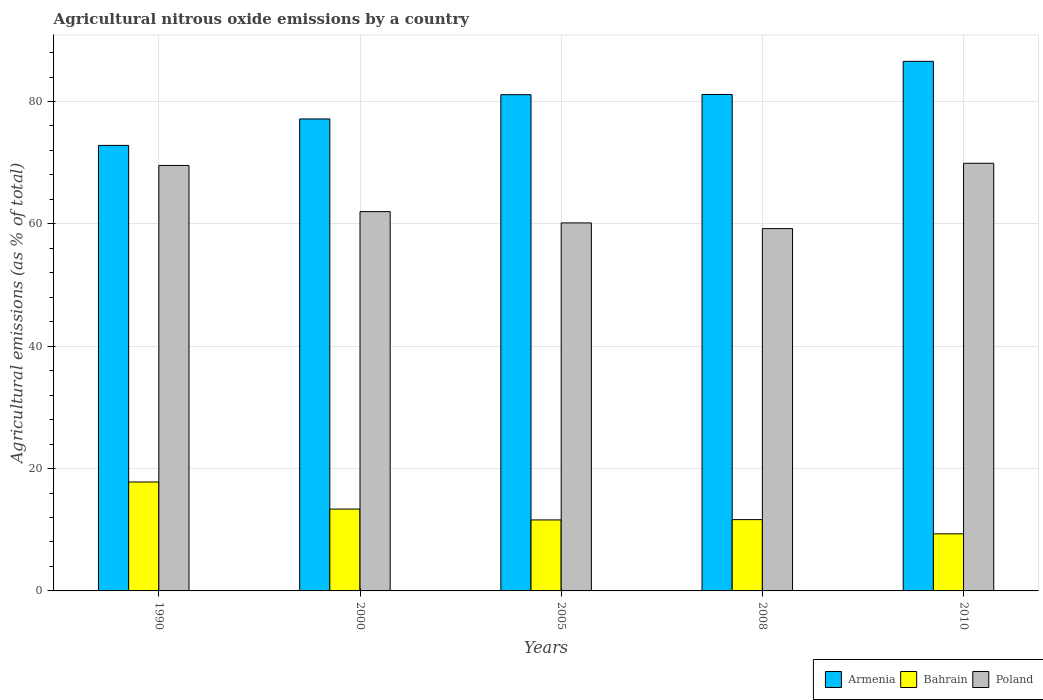How many different coloured bars are there?
Your response must be concise. 3. How many groups of bars are there?
Provide a short and direct response. 5. Are the number of bars on each tick of the X-axis equal?
Your answer should be compact. Yes. How many bars are there on the 2nd tick from the left?
Your response must be concise. 3. In how many cases, is the number of bars for a given year not equal to the number of legend labels?
Your answer should be compact. 0. What is the amount of agricultural nitrous oxide emitted in Bahrain in 2010?
Provide a short and direct response. 9.33. Across all years, what is the maximum amount of agricultural nitrous oxide emitted in Armenia?
Give a very brief answer. 86.56. Across all years, what is the minimum amount of agricultural nitrous oxide emitted in Poland?
Keep it short and to the point. 59.22. What is the total amount of agricultural nitrous oxide emitted in Poland in the graph?
Keep it short and to the point. 320.82. What is the difference between the amount of agricultural nitrous oxide emitted in Poland in 2000 and that in 2005?
Ensure brevity in your answer.  1.85. What is the difference between the amount of agricultural nitrous oxide emitted in Bahrain in 2008 and the amount of agricultural nitrous oxide emitted in Armenia in 2005?
Offer a terse response. -69.46. What is the average amount of agricultural nitrous oxide emitted in Armenia per year?
Give a very brief answer. 79.76. In the year 2010, what is the difference between the amount of agricultural nitrous oxide emitted in Bahrain and amount of agricultural nitrous oxide emitted in Armenia?
Offer a terse response. -77.23. What is the ratio of the amount of agricultural nitrous oxide emitted in Armenia in 1990 to that in 2008?
Give a very brief answer. 0.9. Is the amount of agricultural nitrous oxide emitted in Poland in 2005 less than that in 2008?
Your answer should be compact. No. What is the difference between the highest and the second highest amount of agricultural nitrous oxide emitted in Armenia?
Provide a succinct answer. 5.41. What is the difference between the highest and the lowest amount of agricultural nitrous oxide emitted in Poland?
Your response must be concise. 10.68. In how many years, is the amount of agricultural nitrous oxide emitted in Poland greater than the average amount of agricultural nitrous oxide emitted in Poland taken over all years?
Your answer should be very brief. 2. Is the sum of the amount of agricultural nitrous oxide emitted in Armenia in 2005 and 2008 greater than the maximum amount of agricultural nitrous oxide emitted in Poland across all years?
Provide a short and direct response. Yes. What does the 3rd bar from the right in 2000 represents?
Your answer should be very brief. Armenia. How many bars are there?
Make the answer very short. 15. Are all the bars in the graph horizontal?
Offer a terse response. No. Does the graph contain any zero values?
Give a very brief answer. No. Where does the legend appear in the graph?
Provide a succinct answer. Bottom right. How many legend labels are there?
Provide a succinct answer. 3. How are the legend labels stacked?
Your answer should be very brief. Horizontal. What is the title of the graph?
Provide a succinct answer. Agricultural nitrous oxide emissions by a country. Does "Cyprus" appear as one of the legend labels in the graph?
Provide a succinct answer. No. What is the label or title of the X-axis?
Your response must be concise. Years. What is the label or title of the Y-axis?
Provide a succinct answer. Agricultural emissions (as % of total). What is the Agricultural emissions (as % of total) in Armenia in 1990?
Provide a short and direct response. 72.82. What is the Agricultural emissions (as % of total) in Bahrain in 1990?
Provide a succinct answer. 17.81. What is the Agricultural emissions (as % of total) of Poland in 1990?
Ensure brevity in your answer.  69.54. What is the Agricultural emissions (as % of total) in Armenia in 2000?
Make the answer very short. 77.14. What is the Agricultural emissions (as % of total) in Bahrain in 2000?
Ensure brevity in your answer.  13.38. What is the Agricultural emissions (as % of total) of Poland in 2000?
Offer a very short reply. 62. What is the Agricultural emissions (as % of total) of Armenia in 2005?
Offer a terse response. 81.11. What is the Agricultural emissions (as % of total) in Bahrain in 2005?
Offer a terse response. 11.6. What is the Agricultural emissions (as % of total) of Poland in 2005?
Give a very brief answer. 60.15. What is the Agricultural emissions (as % of total) of Armenia in 2008?
Ensure brevity in your answer.  81.15. What is the Agricultural emissions (as % of total) in Bahrain in 2008?
Keep it short and to the point. 11.65. What is the Agricultural emissions (as % of total) in Poland in 2008?
Offer a terse response. 59.22. What is the Agricultural emissions (as % of total) of Armenia in 2010?
Give a very brief answer. 86.56. What is the Agricultural emissions (as % of total) in Bahrain in 2010?
Offer a terse response. 9.33. What is the Agricultural emissions (as % of total) in Poland in 2010?
Provide a short and direct response. 69.9. Across all years, what is the maximum Agricultural emissions (as % of total) of Armenia?
Make the answer very short. 86.56. Across all years, what is the maximum Agricultural emissions (as % of total) of Bahrain?
Your response must be concise. 17.81. Across all years, what is the maximum Agricultural emissions (as % of total) in Poland?
Your response must be concise. 69.9. Across all years, what is the minimum Agricultural emissions (as % of total) in Armenia?
Provide a short and direct response. 72.82. Across all years, what is the minimum Agricultural emissions (as % of total) in Bahrain?
Offer a terse response. 9.33. Across all years, what is the minimum Agricultural emissions (as % of total) in Poland?
Provide a short and direct response. 59.22. What is the total Agricultural emissions (as % of total) in Armenia in the graph?
Offer a very short reply. 398.78. What is the total Agricultural emissions (as % of total) in Bahrain in the graph?
Your answer should be compact. 63.77. What is the total Agricultural emissions (as % of total) in Poland in the graph?
Keep it short and to the point. 320.82. What is the difference between the Agricultural emissions (as % of total) in Armenia in 1990 and that in 2000?
Your answer should be compact. -4.32. What is the difference between the Agricultural emissions (as % of total) in Bahrain in 1990 and that in 2000?
Offer a very short reply. 4.43. What is the difference between the Agricultural emissions (as % of total) of Poland in 1990 and that in 2000?
Your answer should be compact. 7.54. What is the difference between the Agricultural emissions (as % of total) of Armenia in 1990 and that in 2005?
Provide a short and direct response. -8.29. What is the difference between the Agricultural emissions (as % of total) of Bahrain in 1990 and that in 2005?
Your answer should be very brief. 6.2. What is the difference between the Agricultural emissions (as % of total) of Poland in 1990 and that in 2005?
Your answer should be very brief. 9.39. What is the difference between the Agricultural emissions (as % of total) of Armenia in 1990 and that in 2008?
Your answer should be compact. -8.33. What is the difference between the Agricultural emissions (as % of total) in Bahrain in 1990 and that in 2008?
Give a very brief answer. 6.15. What is the difference between the Agricultural emissions (as % of total) of Poland in 1990 and that in 2008?
Offer a terse response. 10.32. What is the difference between the Agricultural emissions (as % of total) in Armenia in 1990 and that in 2010?
Your response must be concise. -13.74. What is the difference between the Agricultural emissions (as % of total) in Bahrain in 1990 and that in 2010?
Offer a terse response. 8.47. What is the difference between the Agricultural emissions (as % of total) of Poland in 1990 and that in 2010?
Provide a succinct answer. -0.36. What is the difference between the Agricultural emissions (as % of total) in Armenia in 2000 and that in 2005?
Ensure brevity in your answer.  -3.97. What is the difference between the Agricultural emissions (as % of total) in Bahrain in 2000 and that in 2005?
Provide a short and direct response. 1.78. What is the difference between the Agricultural emissions (as % of total) in Poland in 2000 and that in 2005?
Keep it short and to the point. 1.85. What is the difference between the Agricultural emissions (as % of total) of Armenia in 2000 and that in 2008?
Offer a very short reply. -4. What is the difference between the Agricultural emissions (as % of total) in Bahrain in 2000 and that in 2008?
Your response must be concise. 1.72. What is the difference between the Agricultural emissions (as % of total) of Poland in 2000 and that in 2008?
Make the answer very short. 2.78. What is the difference between the Agricultural emissions (as % of total) in Armenia in 2000 and that in 2010?
Your answer should be very brief. -9.42. What is the difference between the Agricultural emissions (as % of total) of Bahrain in 2000 and that in 2010?
Offer a very short reply. 4.05. What is the difference between the Agricultural emissions (as % of total) of Poland in 2000 and that in 2010?
Your answer should be very brief. -7.9. What is the difference between the Agricultural emissions (as % of total) in Armenia in 2005 and that in 2008?
Keep it short and to the point. -0.03. What is the difference between the Agricultural emissions (as % of total) of Bahrain in 2005 and that in 2008?
Provide a succinct answer. -0.05. What is the difference between the Agricultural emissions (as % of total) of Poland in 2005 and that in 2008?
Keep it short and to the point. 0.93. What is the difference between the Agricultural emissions (as % of total) of Armenia in 2005 and that in 2010?
Make the answer very short. -5.45. What is the difference between the Agricultural emissions (as % of total) in Bahrain in 2005 and that in 2010?
Give a very brief answer. 2.27. What is the difference between the Agricultural emissions (as % of total) in Poland in 2005 and that in 2010?
Offer a terse response. -9.75. What is the difference between the Agricultural emissions (as % of total) in Armenia in 2008 and that in 2010?
Provide a short and direct response. -5.41. What is the difference between the Agricultural emissions (as % of total) of Bahrain in 2008 and that in 2010?
Ensure brevity in your answer.  2.32. What is the difference between the Agricultural emissions (as % of total) of Poland in 2008 and that in 2010?
Your answer should be very brief. -10.68. What is the difference between the Agricultural emissions (as % of total) of Armenia in 1990 and the Agricultural emissions (as % of total) of Bahrain in 2000?
Keep it short and to the point. 59.44. What is the difference between the Agricultural emissions (as % of total) in Armenia in 1990 and the Agricultural emissions (as % of total) in Poland in 2000?
Keep it short and to the point. 10.82. What is the difference between the Agricultural emissions (as % of total) in Bahrain in 1990 and the Agricultural emissions (as % of total) in Poland in 2000?
Offer a very short reply. -44.19. What is the difference between the Agricultural emissions (as % of total) of Armenia in 1990 and the Agricultural emissions (as % of total) of Bahrain in 2005?
Make the answer very short. 61.22. What is the difference between the Agricultural emissions (as % of total) of Armenia in 1990 and the Agricultural emissions (as % of total) of Poland in 2005?
Your answer should be very brief. 12.67. What is the difference between the Agricultural emissions (as % of total) of Bahrain in 1990 and the Agricultural emissions (as % of total) of Poland in 2005?
Your answer should be compact. -42.35. What is the difference between the Agricultural emissions (as % of total) in Armenia in 1990 and the Agricultural emissions (as % of total) in Bahrain in 2008?
Your response must be concise. 61.17. What is the difference between the Agricultural emissions (as % of total) in Armenia in 1990 and the Agricultural emissions (as % of total) in Poland in 2008?
Provide a short and direct response. 13.6. What is the difference between the Agricultural emissions (as % of total) in Bahrain in 1990 and the Agricultural emissions (as % of total) in Poland in 2008?
Keep it short and to the point. -41.41. What is the difference between the Agricultural emissions (as % of total) of Armenia in 1990 and the Agricultural emissions (as % of total) of Bahrain in 2010?
Ensure brevity in your answer.  63.49. What is the difference between the Agricultural emissions (as % of total) of Armenia in 1990 and the Agricultural emissions (as % of total) of Poland in 2010?
Your response must be concise. 2.92. What is the difference between the Agricultural emissions (as % of total) in Bahrain in 1990 and the Agricultural emissions (as % of total) in Poland in 2010?
Give a very brief answer. -52.09. What is the difference between the Agricultural emissions (as % of total) in Armenia in 2000 and the Agricultural emissions (as % of total) in Bahrain in 2005?
Ensure brevity in your answer.  65.54. What is the difference between the Agricultural emissions (as % of total) in Armenia in 2000 and the Agricultural emissions (as % of total) in Poland in 2005?
Give a very brief answer. 16.99. What is the difference between the Agricultural emissions (as % of total) in Bahrain in 2000 and the Agricultural emissions (as % of total) in Poland in 2005?
Offer a terse response. -46.77. What is the difference between the Agricultural emissions (as % of total) of Armenia in 2000 and the Agricultural emissions (as % of total) of Bahrain in 2008?
Your answer should be compact. 65.49. What is the difference between the Agricultural emissions (as % of total) of Armenia in 2000 and the Agricultural emissions (as % of total) of Poland in 2008?
Offer a terse response. 17.92. What is the difference between the Agricultural emissions (as % of total) of Bahrain in 2000 and the Agricultural emissions (as % of total) of Poland in 2008?
Your answer should be compact. -45.84. What is the difference between the Agricultural emissions (as % of total) in Armenia in 2000 and the Agricultural emissions (as % of total) in Bahrain in 2010?
Provide a short and direct response. 67.81. What is the difference between the Agricultural emissions (as % of total) of Armenia in 2000 and the Agricultural emissions (as % of total) of Poland in 2010?
Provide a short and direct response. 7.24. What is the difference between the Agricultural emissions (as % of total) in Bahrain in 2000 and the Agricultural emissions (as % of total) in Poland in 2010?
Offer a very short reply. -56.52. What is the difference between the Agricultural emissions (as % of total) in Armenia in 2005 and the Agricultural emissions (as % of total) in Bahrain in 2008?
Provide a short and direct response. 69.46. What is the difference between the Agricultural emissions (as % of total) of Armenia in 2005 and the Agricultural emissions (as % of total) of Poland in 2008?
Your answer should be compact. 21.89. What is the difference between the Agricultural emissions (as % of total) of Bahrain in 2005 and the Agricultural emissions (as % of total) of Poland in 2008?
Your response must be concise. -47.62. What is the difference between the Agricultural emissions (as % of total) of Armenia in 2005 and the Agricultural emissions (as % of total) of Bahrain in 2010?
Your answer should be very brief. 71.78. What is the difference between the Agricultural emissions (as % of total) of Armenia in 2005 and the Agricultural emissions (as % of total) of Poland in 2010?
Make the answer very short. 11.21. What is the difference between the Agricultural emissions (as % of total) of Bahrain in 2005 and the Agricultural emissions (as % of total) of Poland in 2010?
Provide a short and direct response. -58.3. What is the difference between the Agricultural emissions (as % of total) in Armenia in 2008 and the Agricultural emissions (as % of total) in Bahrain in 2010?
Give a very brief answer. 71.81. What is the difference between the Agricultural emissions (as % of total) in Armenia in 2008 and the Agricultural emissions (as % of total) in Poland in 2010?
Offer a very short reply. 11.25. What is the difference between the Agricultural emissions (as % of total) in Bahrain in 2008 and the Agricultural emissions (as % of total) in Poland in 2010?
Ensure brevity in your answer.  -58.25. What is the average Agricultural emissions (as % of total) of Armenia per year?
Provide a short and direct response. 79.76. What is the average Agricultural emissions (as % of total) in Bahrain per year?
Offer a very short reply. 12.75. What is the average Agricultural emissions (as % of total) of Poland per year?
Make the answer very short. 64.16. In the year 1990, what is the difference between the Agricultural emissions (as % of total) in Armenia and Agricultural emissions (as % of total) in Bahrain?
Offer a terse response. 55.01. In the year 1990, what is the difference between the Agricultural emissions (as % of total) of Armenia and Agricultural emissions (as % of total) of Poland?
Offer a very short reply. 3.28. In the year 1990, what is the difference between the Agricultural emissions (as % of total) in Bahrain and Agricultural emissions (as % of total) in Poland?
Make the answer very short. -51.74. In the year 2000, what is the difference between the Agricultural emissions (as % of total) of Armenia and Agricultural emissions (as % of total) of Bahrain?
Provide a short and direct response. 63.77. In the year 2000, what is the difference between the Agricultural emissions (as % of total) in Armenia and Agricultural emissions (as % of total) in Poland?
Offer a very short reply. 15.14. In the year 2000, what is the difference between the Agricultural emissions (as % of total) in Bahrain and Agricultural emissions (as % of total) in Poland?
Give a very brief answer. -48.62. In the year 2005, what is the difference between the Agricultural emissions (as % of total) in Armenia and Agricultural emissions (as % of total) in Bahrain?
Make the answer very short. 69.51. In the year 2005, what is the difference between the Agricultural emissions (as % of total) of Armenia and Agricultural emissions (as % of total) of Poland?
Your answer should be compact. 20.96. In the year 2005, what is the difference between the Agricultural emissions (as % of total) in Bahrain and Agricultural emissions (as % of total) in Poland?
Give a very brief answer. -48.55. In the year 2008, what is the difference between the Agricultural emissions (as % of total) in Armenia and Agricultural emissions (as % of total) in Bahrain?
Keep it short and to the point. 69.49. In the year 2008, what is the difference between the Agricultural emissions (as % of total) of Armenia and Agricultural emissions (as % of total) of Poland?
Your response must be concise. 21.93. In the year 2008, what is the difference between the Agricultural emissions (as % of total) in Bahrain and Agricultural emissions (as % of total) in Poland?
Ensure brevity in your answer.  -47.57. In the year 2010, what is the difference between the Agricultural emissions (as % of total) of Armenia and Agricultural emissions (as % of total) of Bahrain?
Provide a succinct answer. 77.23. In the year 2010, what is the difference between the Agricultural emissions (as % of total) of Armenia and Agricultural emissions (as % of total) of Poland?
Your response must be concise. 16.66. In the year 2010, what is the difference between the Agricultural emissions (as % of total) in Bahrain and Agricultural emissions (as % of total) in Poland?
Offer a terse response. -60.57. What is the ratio of the Agricultural emissions (as % of total) of Armenia in 1990 to that in 2000?
Provide a short and direct response. 0.94. What is the ratio of the Agricultural emissions (as % of total) of Bahrain in 1990 to that in 2000?
Keep it short and to the point. 1.33. What is the ratio of the Agricultural emissions (as % of total) of Poland in 1990 to that in 2000?
Offer a terse response. 1.12. What is the ratio of the Agricultural emissions (as % of total) of Armenia in 1990 to that in 2005?
Offer a terse response. 0.9. What is the ratio of the Agricultural emissions (as % of total) of Bahrain in 1990 to that in 2005?
Keep it short and to the point. 1.53. What is the ratio of the Agricultural emissions (as % of total) in Poland in 1990 to that in 2005?
Give a very brief answer. 1.16. What is the ratio of the Agricultural emissions (as % of total) of Armenia in 1990 to that in 2008?
Keep it short and to the point. 0.9. What is the ratio of the Agricultural emissions (as % of total) in Bahrain in 1990 to that in 2008?
Your answer should be compact. 1.53. What is the ratio of the Agricultural emissions (as % of total) in Poland in 1990 to that in 2008?
Provide a succinct answer. 1.17. What is the ratio of the Agricultural emissions (as % of total) of Armenia in 1990 to that in 2010?
Give a very brief answer. 0.84. What is the ratio of the Agricultural emissions (as % of total) of Bahrain in 1990 to that in 2010?
Provide a short and direct response. 1.91. What is the ratio of the Agricultural emissions (as % of total) in Poland in 1990 to that in 2010?
Give a very brief answer. 0.99. What is the ratio of the Agricultural emissions (as % of total) in Armenia in 2000 to that in 2005?
Keep it short and to the point. 0.95. What is the ratio of the Agricultural emissions (as % of total) in Bahrain in 2000 to that in 2005?
Ensure brevity in your answer.  1.15. What is the ratio of the Agricultural emissions (as % of total) of Poland in 2000 to that in 2005?
Make the answer very short. 1.03. What is the ratio of the Agricultural emissions (as % of total) in Armenia in 2000 to that in 2008?
Ensure brevity in your answer.  0.95. What is the ratio of the Agricultural emissions (as % of total) of Bahrain in 2000 to that in 2008?
Ensure brevity in your answer.  1.15. What is the ratio of the Agricultural emissions (as % of total) of Poland in 2000 to that in 2008?
Provide a succinct answer. 1.05. What is the ratio of the Agricultural emissions (as % of total) of Armenia in 2000 to that in 2010?
Your response must be concise. 0.89. What is the ratio of the Agricultural emissions (as % of total) of Bahrain in 2000 to that in 2010?
Make the answer very short. 1.43. What is the ratio of the Agricultural emissions (as % of total) of Poland in 2000 to that in 2010?
Provide a succinct answer. 0.89. What is the ratio of the Agricultural emissions (as % of total) of Armenia in 2005 to that in 2008?
Provide a succinct answer. 1. What is the ratio of the Agricultural emissions (as % of total) in Bahrain in 2005 to that in 2008?
Keep it short and to the point. 1. What is the ratio of the Agricultural emissions (as % of total) in Poland in 2005 to that in 2008?
Provide a succinct answer. 1.02. What is the ratio of the Agricultural emissions (as % of total) of Armenia in 2005 to that in 2010?
Your answer should be very brief. 0.94. What is the ratio of the Agricultural emissions (as % of total) of Bahrain in 2005 to that in 2010?
Give a very brief answer. 1.24. What is the ratio of the Agricultural emissions (as % of total) in Poland in 2005 to that in 2010?
Make the answer very short. 0.86. What is the ratio of the Agricultural emissions (as % of total) in Armenia in 2008 to that in 2010?
Offer a terse response. 0.94. What is the ratio of the Agricultural emissions (as % of total) in Bahrain in 2008 to that in 2010?
Offer a very short reply. 1.25. What is the ratio of the Agricultural emissions (as % of total) in Poland in 2008 to that in 2010?
Give a very brief answer. 0.85. What is the difference between the highest and the second highest Agricultural emissions (as % of total) in Armenia?
Give a very brief answer. 5.41. What is the difference between the highest and the second highest Agricultural emissions (as % of total) in Bahrain?
Your answer should be compact. 4.43. What is the difference between the highest and the second highest Agricultural emissions (as % of total) of Poland?
Your response must be concise. 0.36. What is the difference between the highest and the lowest Agricultural emissions (as % of total) of Armenia?
Ensure brevity in your answer.  13.74. What is the difference between the highest and the lowest Agricultural emissions (as % of total) of Bahrain?
Offer a terse response. 8.47. What is the difference between the highest and the lowest Agricultural emissions (as % of total) in Poland?
Provide a short and direct response. 10.68. 